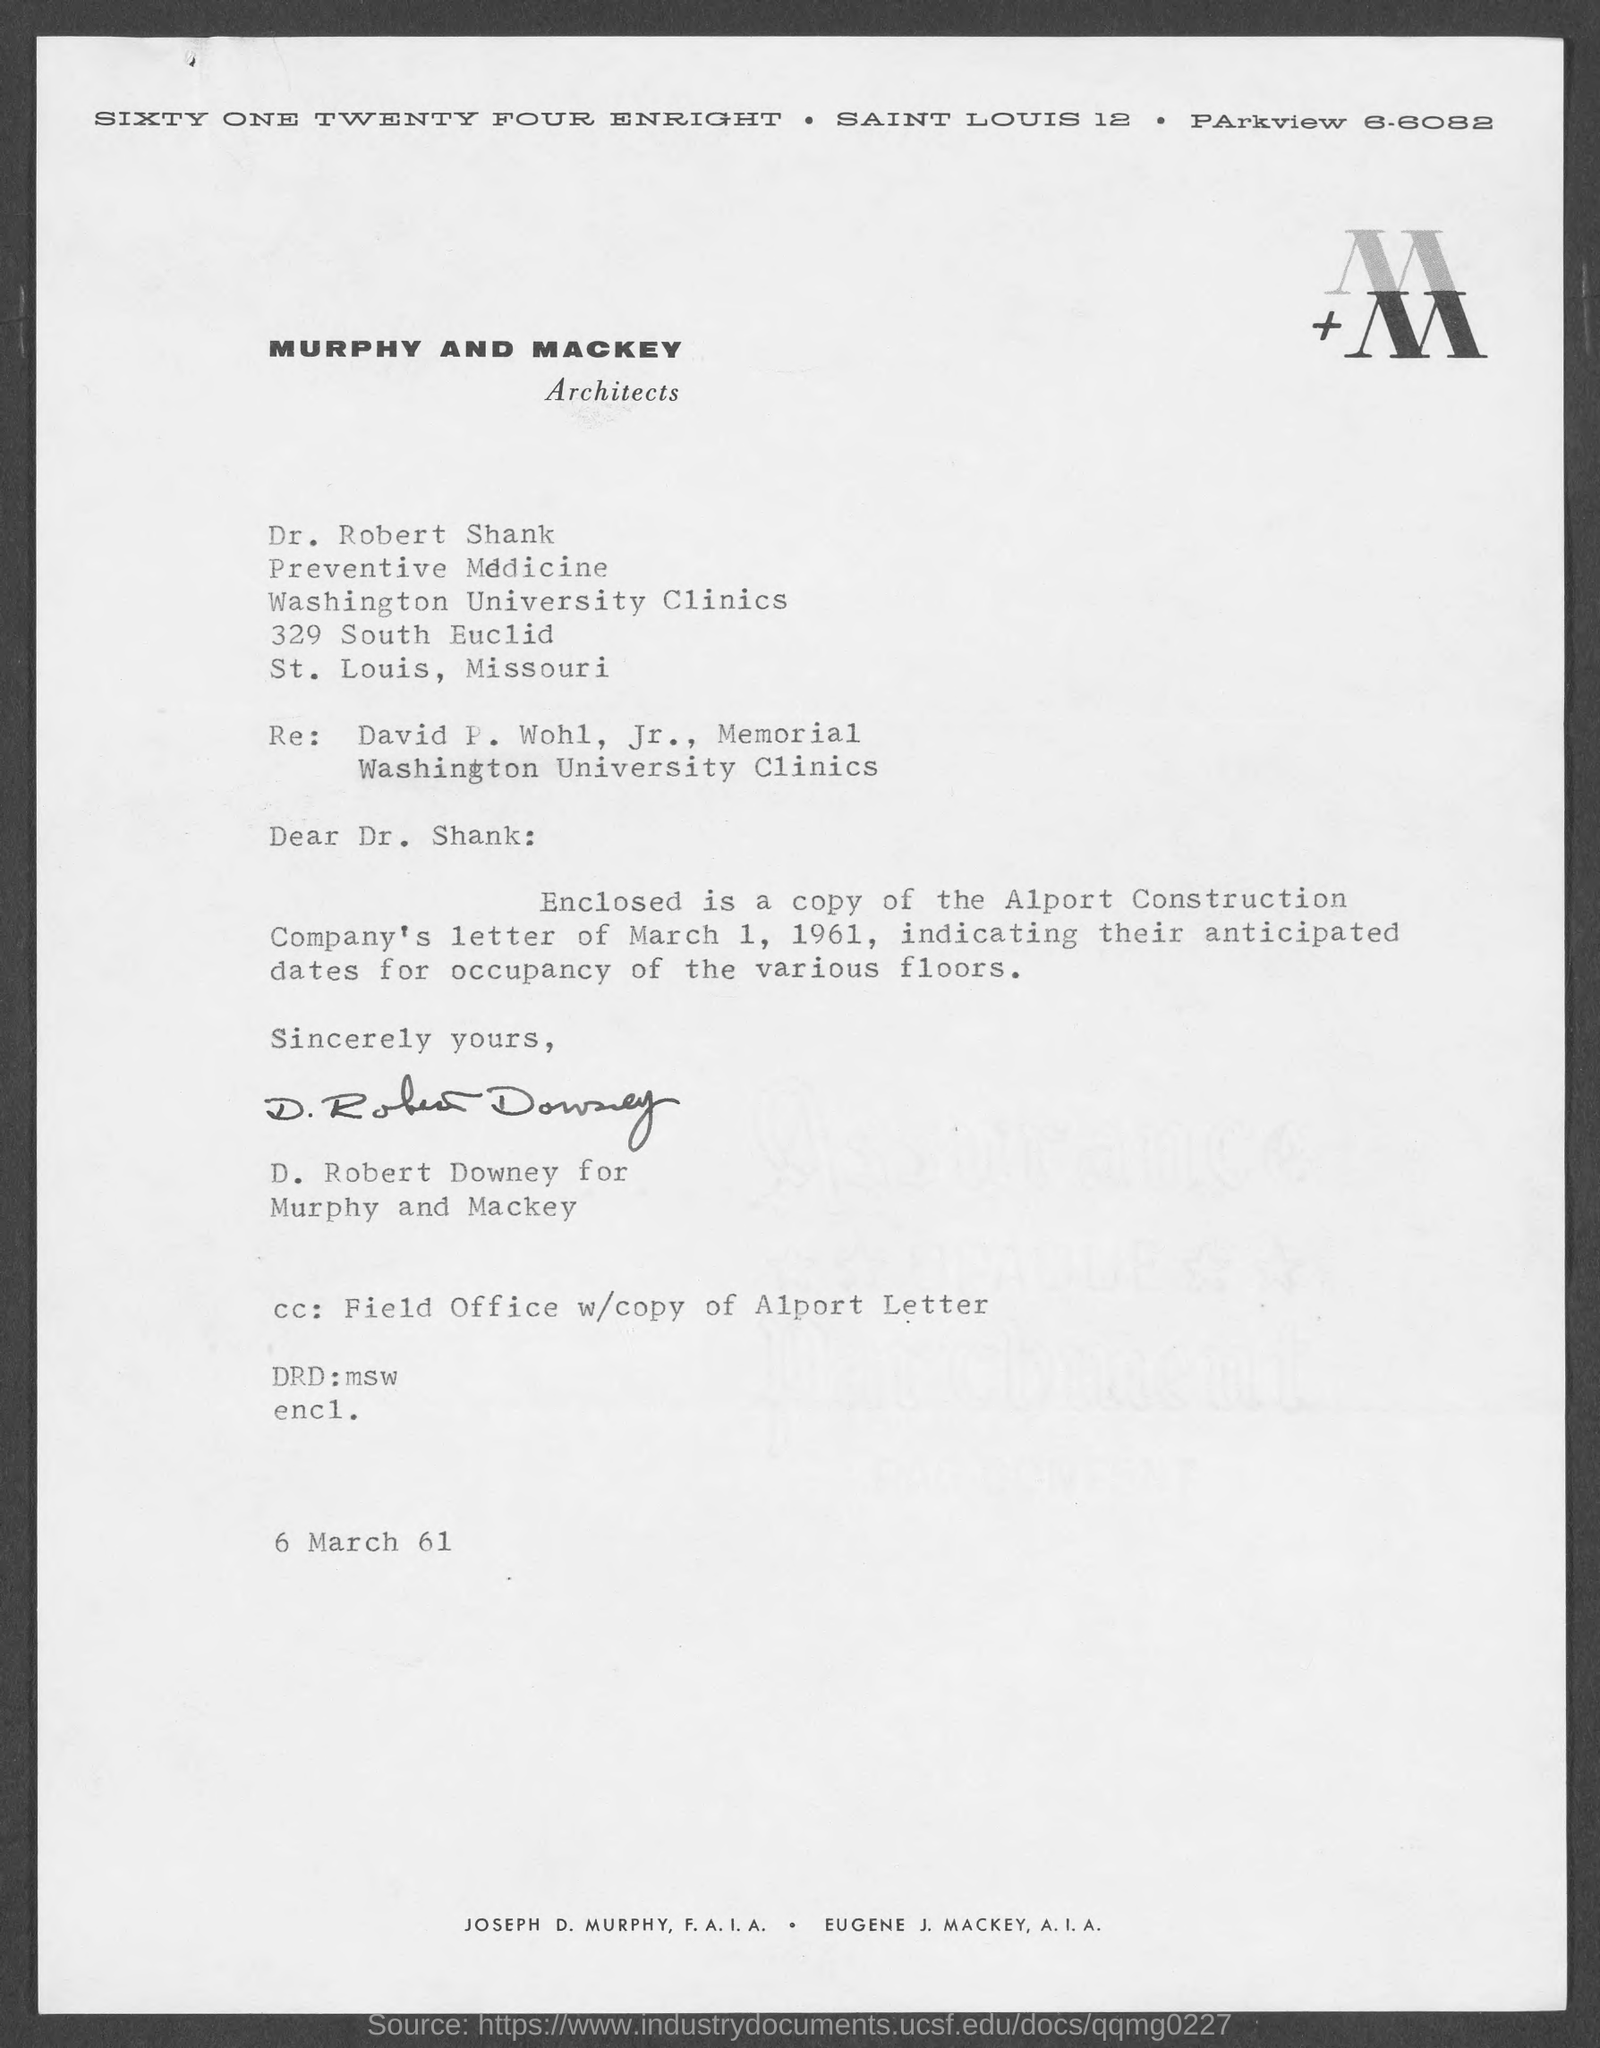Highlight a few significant elements in this photo. The memorandum is addressed to Dr. Robert Shank. The writer of this letter is D. Robert Downey. The date mentioned at the bottom of the document is March 6, 1961. The DRD field contains information that has been written by a software development kit (MSW). 